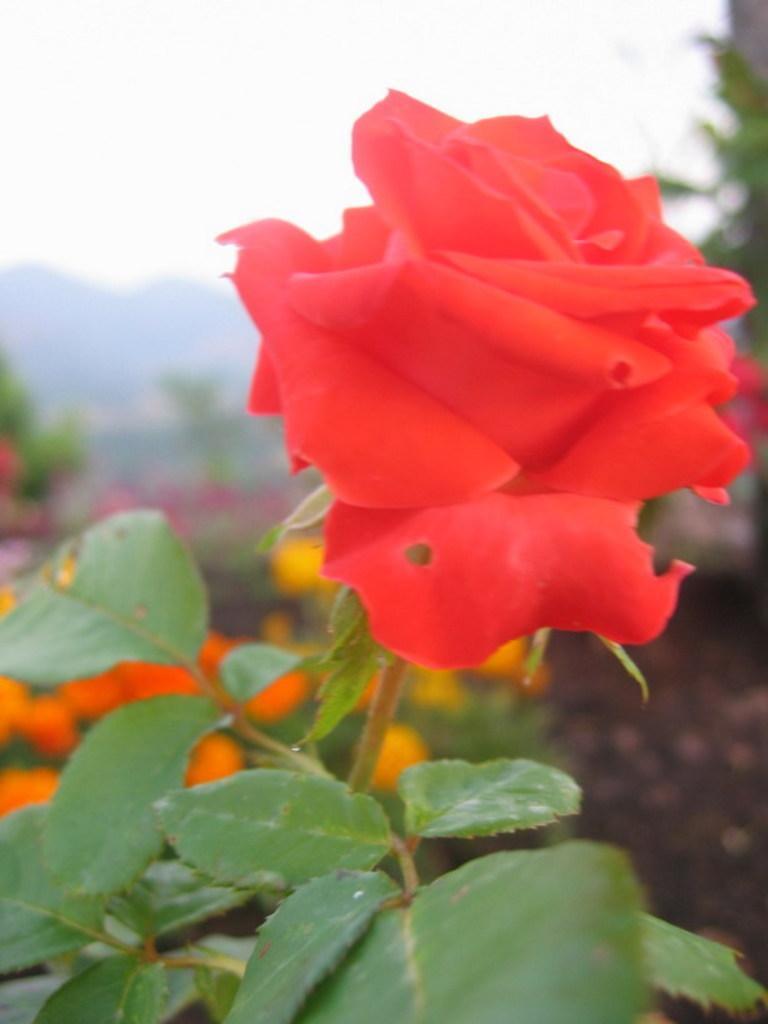Please provide a concise description of this image. In this image I can see a flower which is red in color to a tree which is green in color. In the background I can see few trees, few flowers which are red and orange in color and the sky. 